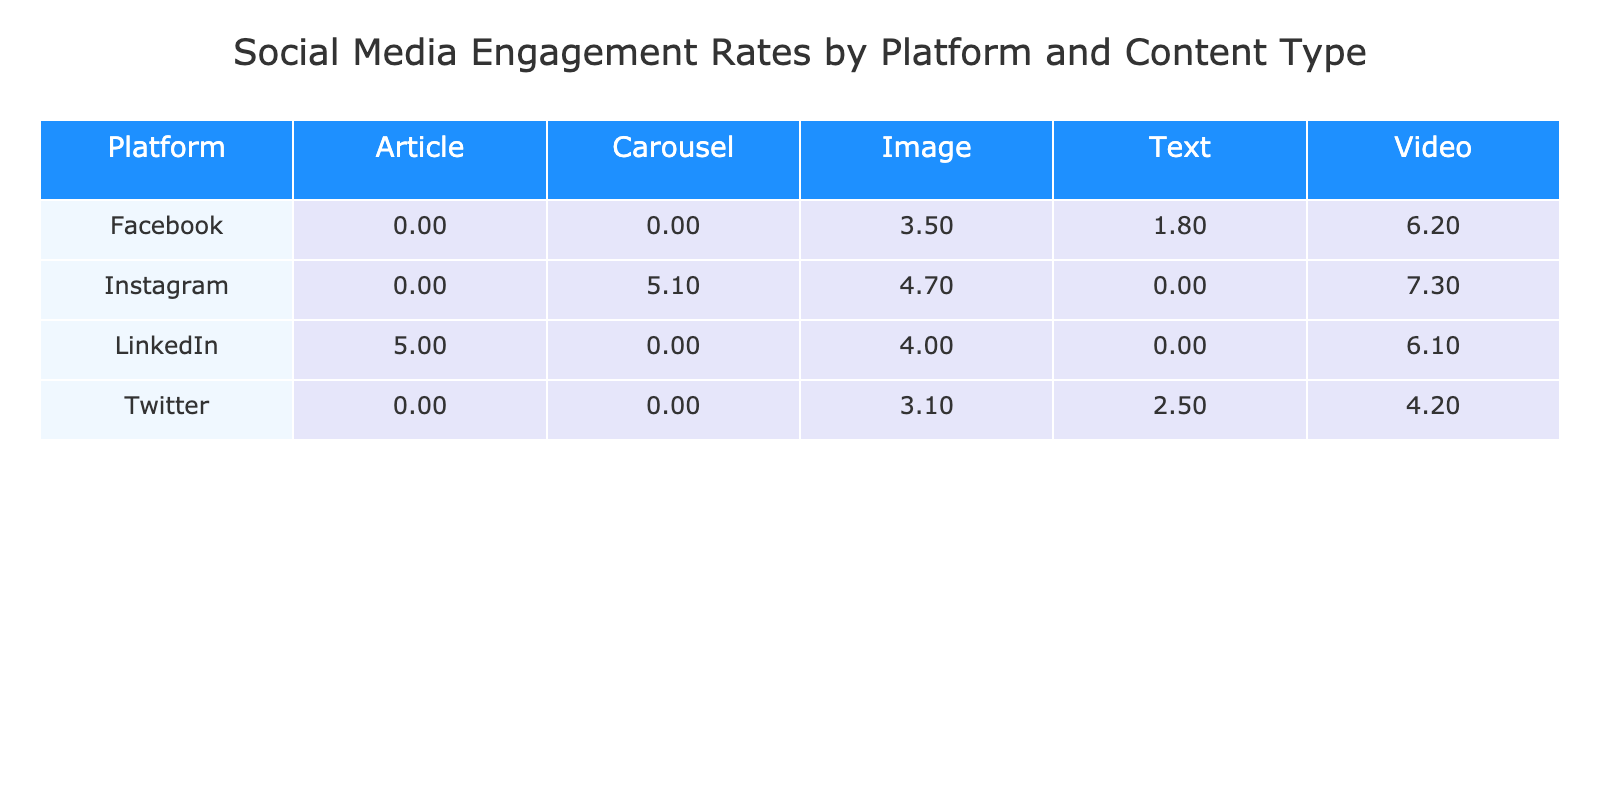What is the engagement rate for Instagram Video? The table shows that the engagement rate for Instagram Video is listed directly under the Instagram row and the Video column. Finding this value gives us 7.3%.
Answer: 7.3% Which platform has the highest engagement rate for Image content? To determine this, we compare the engagement rates for the Image content type across all platforms: Facebook (3.5%), Instagram (4.7%), Twitter (3.1%), and LinkedIn (4.0%). The highest is Instagram with 4.7%.
Answer: Instagram What is the average engagement rate for Facebook content? To find the average, we need to sum the engagement rates for each content type under Facebook: 3.5% (Image), 6.2% (Video), and 1.8% (Text). The sum is 3.5 + 6.2 + 1.8 = 11.5%. Then we divide by the number of content types (3) to find the average: 11.5/3 = 3.83%.
Answer: 3.83% Is the engagement rate for LinkedIn Article higher than 5%? Referring to the table, the engagement rate for LinkedIn Article is 5.0%. Since 5.0% is not greater than 5%, the answer is no.
Answer: No How does the average engagement rate for videos across all platforms compare to the engagement rate of Twitter Video? First, we calculate the average engagement rate for videos: Facebook (6.2%), Instagram (7.3%), and LinkedIn (6.1%). The sum is 6.2 + 7.3 + 6.1 = 19.6%, and there are 3 entries, so the average is 19.6/3 = 6.53%. Now compare this to Twitter Video, which has an engagement rate of 4.2%. Since 6.53% is greater than 4.2%, the answer is yes.
Answer: Yes Which content type has the lowest average engagement rate across all platforms? We need to assess engagement rates for all content types: Image (average of 3.5%, 4.7%, 3.1%, 4.0%), Video (average of 6.2%, 7.3%, 6.1%), Text (average of 1.8%, 2.5%), and Carousel (5.1%). The average for Text is the lowest: (1.8 + 2.5) / 2 = 2.15%.
Answer: Text What is the difference in engagement rate between the highest and lowest for all types of content? The highest engagement rate in the table is Instagram Video (7.3%), and the lowest for Text (1.8%). To find the difference, subtract the lowest from the highest: 7.3 - 1.8 = 5.5%.
Answer: 5.5% Which platform has the second-highest engagement rate for videos? From the data, the engagement rates for videos are: Facebook (6.2%), Instagram (7.3%), and LinkedIn (6.1%). Ranking these gives us Instagram as the highest (7.3%), Facebook as second (6.2%), and LinkedIn (6.1%) as the third. Therefore, the platform with the second-highest is Facebook.
Answer: Facebook 